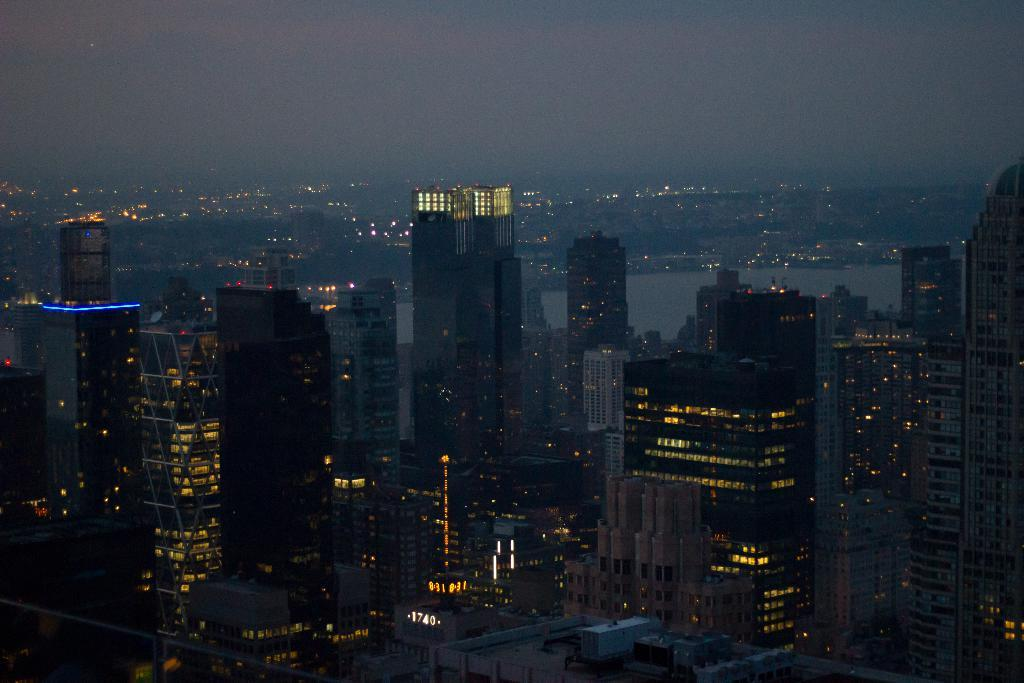What type of structures can be seen in the foreground of the image? There are buildings, towers, and lights visible in the foreground of the image. What natural elements are present in the foreground of the image? There are trees and water visible in the foreground of the image. What part of the natural environment is visible in the image? The sky is visible at the top of the image. What might be the time of day when the image was taken? The image might have been taken during night, as suggested by the presence of lights and the mention of "at the top" for the sky. What type of clam is visible in the image? There are no clams present in the image. What is the name of the bedroom in the image? There is no bedroom present in the image. 